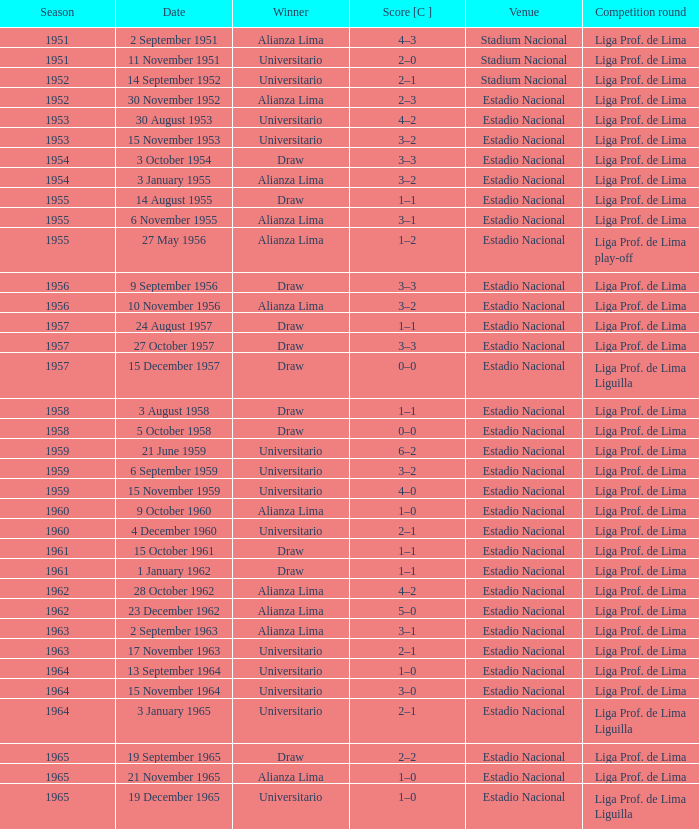In the 1965 event where alianza lima emerged victorious, what was the final score? 1–0. 